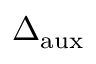Convert formula to latex. <formula><loc_0><loc_0><loc_500><loc_500>\Delta _ { a u x }</formula> 